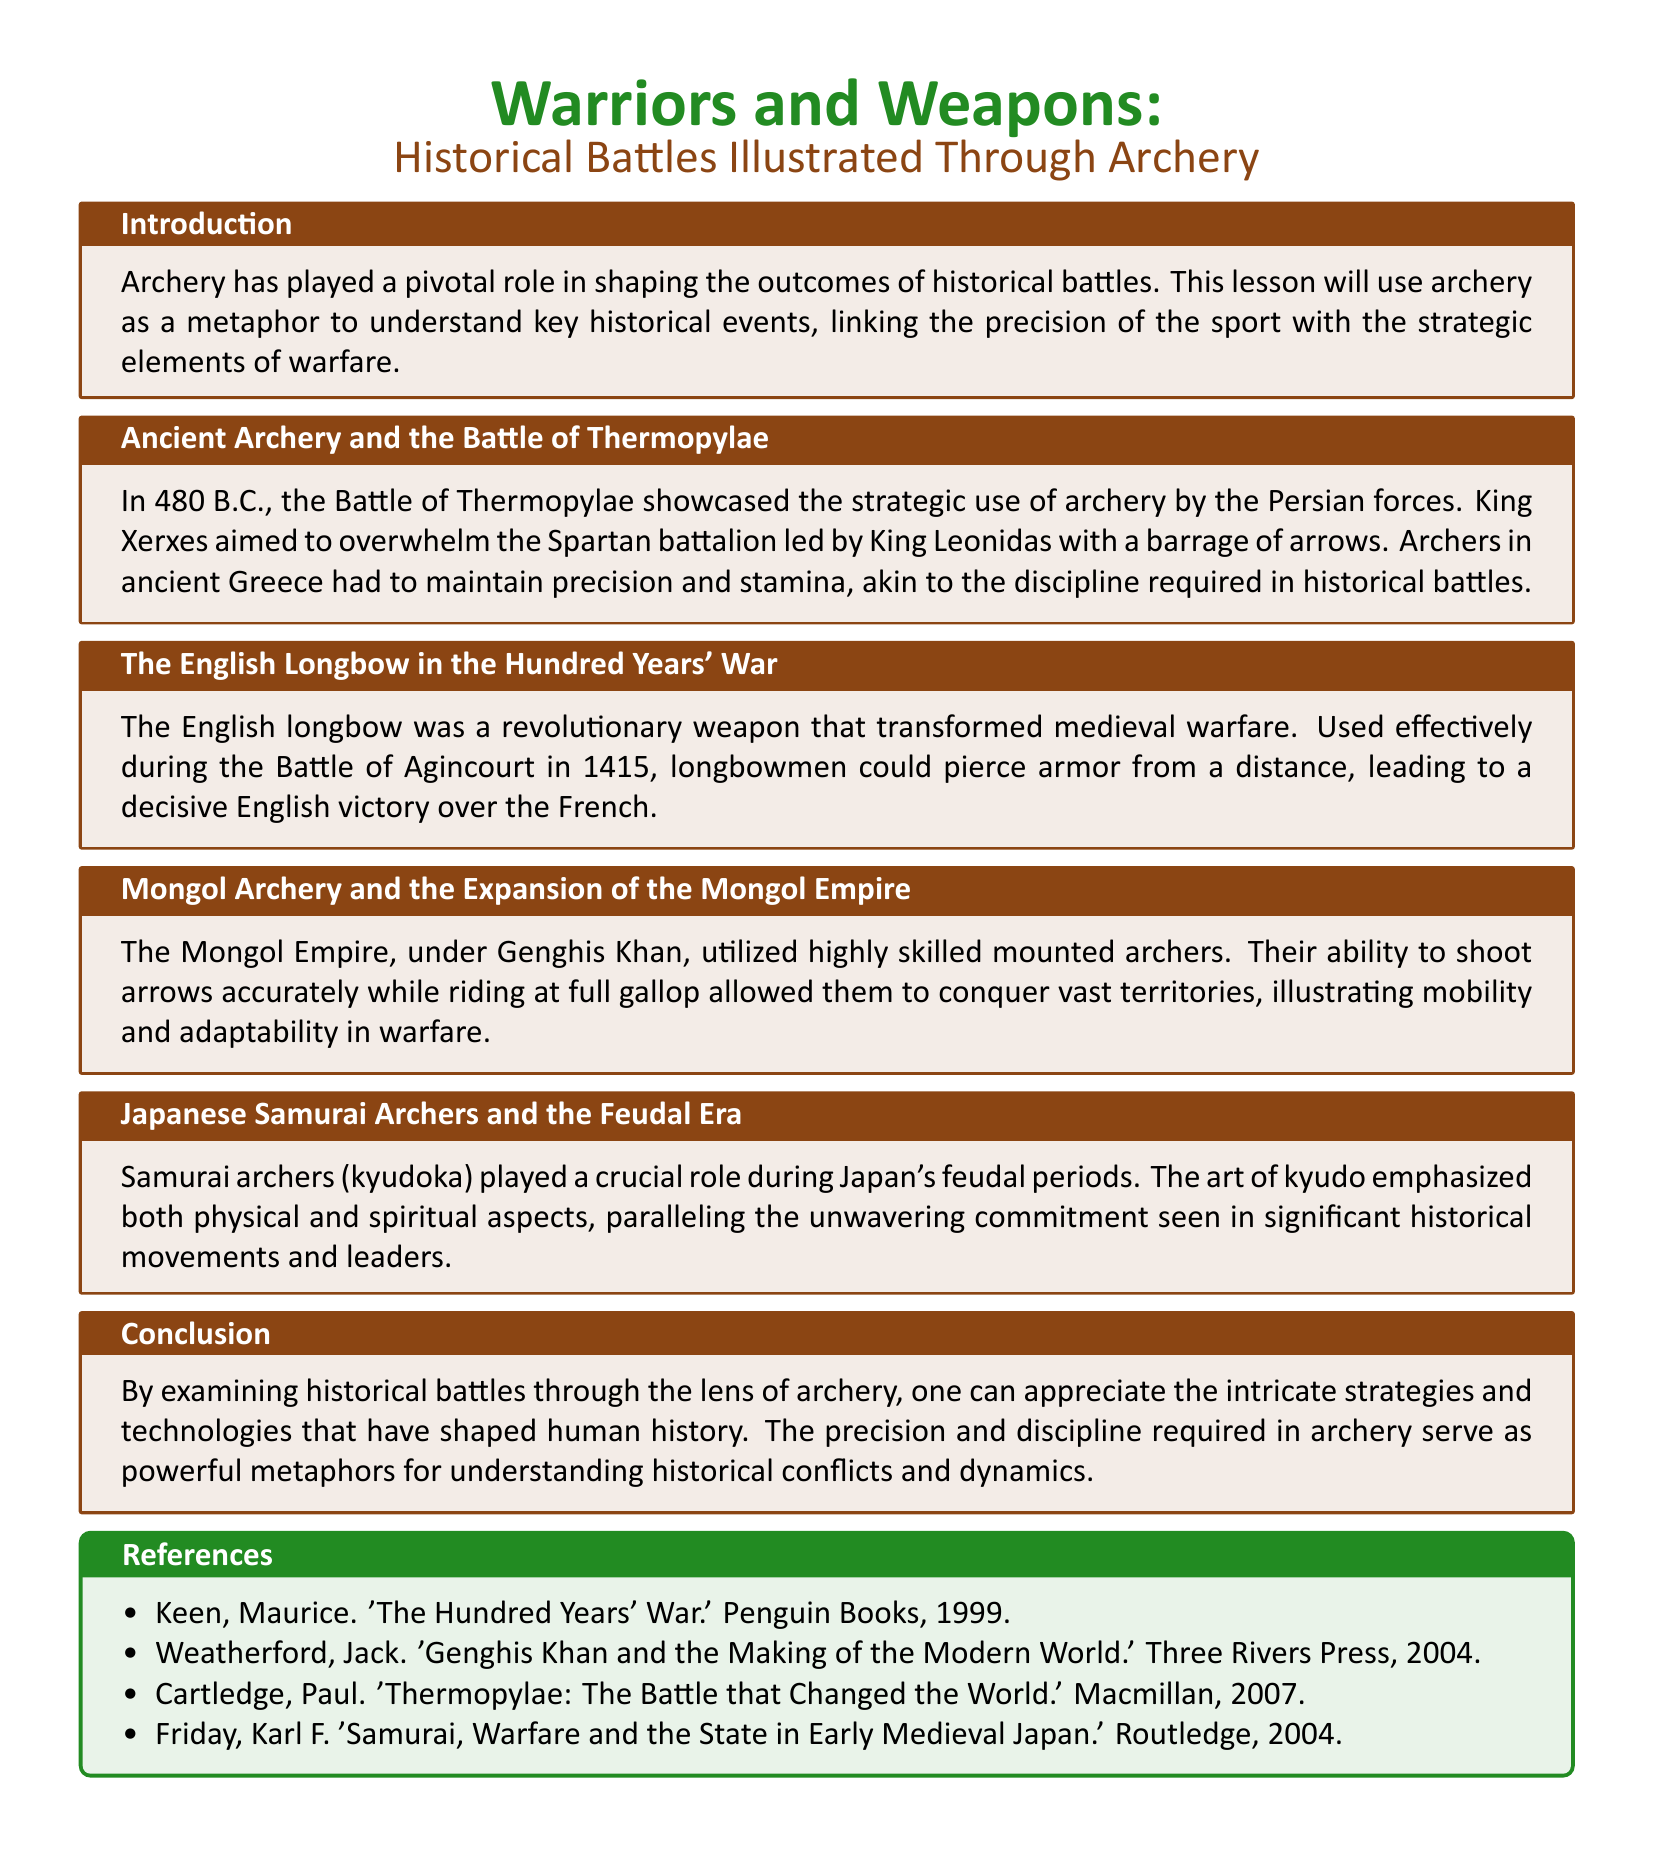What is the main focus of the lesson plan? The lesson plan focuses on understanding historical battles through the metaphor of archery.
Answer: Historical battles In which year did the Battle of Thermopylae occur? The Battle of Thermopylae occurred in 480 B.C.
Answer: 480 B.C What weapon transformed medieval warfare according to the document? The document states that the English longbow transformed medieval warfare.
Answer: English longbow Who led the Persian forces at the Battle of Thermopylae? King Xerxes led the Persian forces at the Battle of Thermopylae.
Answer: King Xerxes Which historical figure is associated with the Mongol expansion in the document? Genghis Khan is associated with the Mongol expansion.
Answer: Genghis Khan What is the significance of the art of kyudo? The art of kyudo emphasizes both physical and spiritual aspects.
Answer: Physical and spiritual aspects During which conflict did longbowmen achieve victory over the French? Longbowmen achieved victory over the French during the Battle of Agincourt in 1415.
Answer: Battle of Agincourt Which reference book discusses the Hundred Years' War? Maurice Keen's book discusses the Hundred Years' War.
Answer: 'The Hundred Years' War' How does the lesson plan suggest archery as a metaphor? The lesson suggests that the precision of archery relates to the strategic elements of warfare.
Answer: Precision and strategy What type of document is this? This is a lesson plan that illustrates historical battles through archery.
Answer: Lesson plan 